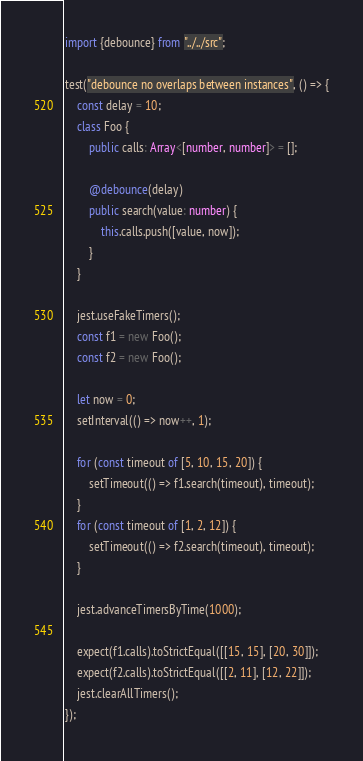<code> <loc_0><loc_0><loc_500><loc_500><_TypeScript_>import {debounce} from "../../src";

test("debounce no overlaps between instances", () => {
    const delay = 10;
    class Foo {
        public calls: Array<[number, number]> = [];

        @debounce(delay)
        public search(value: number) {
            this.calls.push([value, now]);
        }
    }

    jest.useFakeTimers();
    const f1 = new Foo();
    const f2 = new Foo();

    let now = 0;
    setInterval(() => now++, 1);

    for (const timeout of [5, 10, 15, 20]) {
        setTimeout(() => f1.search(timeout), timeout);
    }
    for (const timeout of [1, 2, 12]) {
        setTimeout(() => f2.search(timeout), timeout);
    }

    jest.advanceTimersByTime(1000);

    expect(f1.calls).toStrictEqual([[15, 15], [20, 30]]);
    expect(f2.calls).toStrictEqual([[2, 11], [12, 22]]);
    jest.clearAllTimers();
});
</code> 